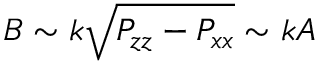<formula> <loc_0><loc_0><loc_500><loc_500>B \sim k \sqrt { P _ { z z } - P _ { x x } } \sim k A</formula> 